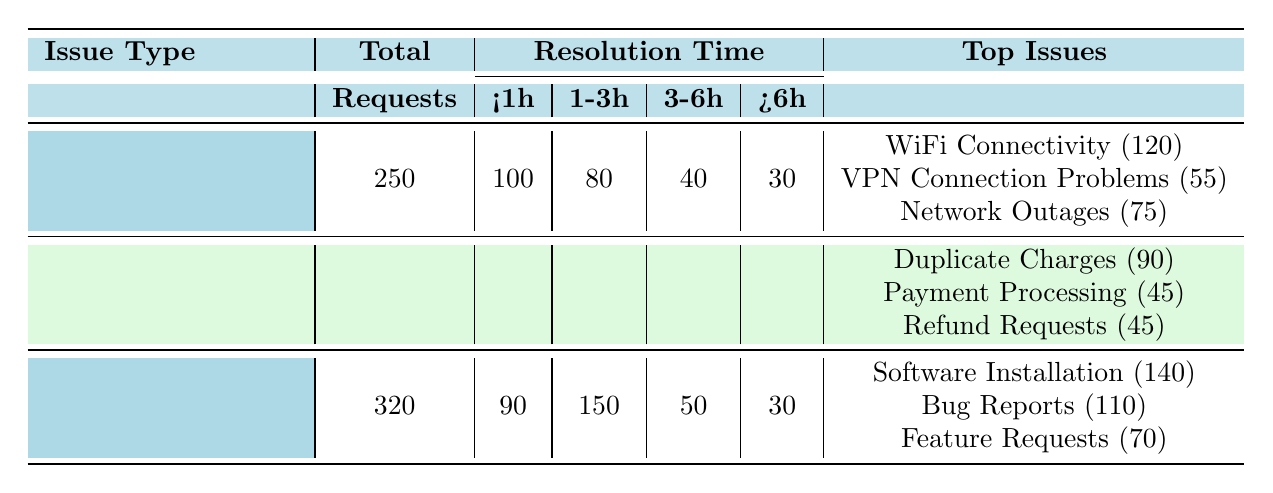What is the total number of customer support requests for Network Issues? The table shows that the total requests for Network Issues is specified directly in the "Total" column for that category. It lists 250 requests.
Answer: 250 How many requests were resolved in under 1 hour for Billing Queries? Referring to the Billing Queries section of the table, the "Under1Hour" column shows 60 requests.
Answer: 60 What is the average resolution time for Refund Requests? The details under Billing Queries specify that Refund Requests had an average resolution time of 6 hours.
Answer: 6 hours Which issue type had the highest total requests? By comparing the total requests for each issue type, Technical Support has the highest total requests at 320 compared to 250 for Network Issues and 180 for Billing Queries.
Answer: Technical Support How many requests for Technical Support were resolved in 1-3 hours? The Technical Support section shows that 150 requests were resolved within the 1-3 hour time frame.
Answer: 150 Is the average resolution time for WiFi Connectivity shorter than that for Bug Reports? The average resolution time for WiFi Connectivity is 1.5 hours, while for Bug Reports, it is 3 hours. Since 1.5 hours is less than 3 hours, the statement is true.
Answer: Yes What percentage of Network Issues were resolved in over 6 hours? Over 6 hours, there were 30 requests out of a total of 250 for Network Issues. To find the percentage: (30/250) * 100 = 12%.
Answer: 12% How many total requests across all categories took longer than 3 hours to resolve? Summing the requests taking over 3 hours in each category, we have: Network Issues (40) + Billing Queries (30) + Technical Support (80) = 150.
Answer: 150 Was there more focus on resolving Billing Queries in under 1 hour compared to Network Issues? In Billing Queries, 60 requests were resolved under 1 hour, while Network Issues resolved 100 requests. Since 100 is greater than 60, the focus was indeed more on Network Issues.
Answer: No 